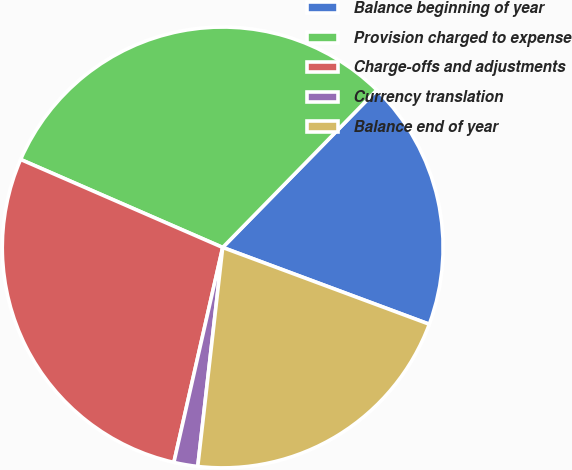<chart> <loc_0><loc_0><loc_500><loc_500><pie_chart><fcel>Balance beginning of year<fcel>Provision charged to expense<fcel>Charge-offs and adjustments<fcel>Currency translation<fcel>Balance end of year<nl><fcel>18.33%<fcel>30.79%<fcel>27.98%<fcel>1.75%<fcel>21.14%<nl></chart> 